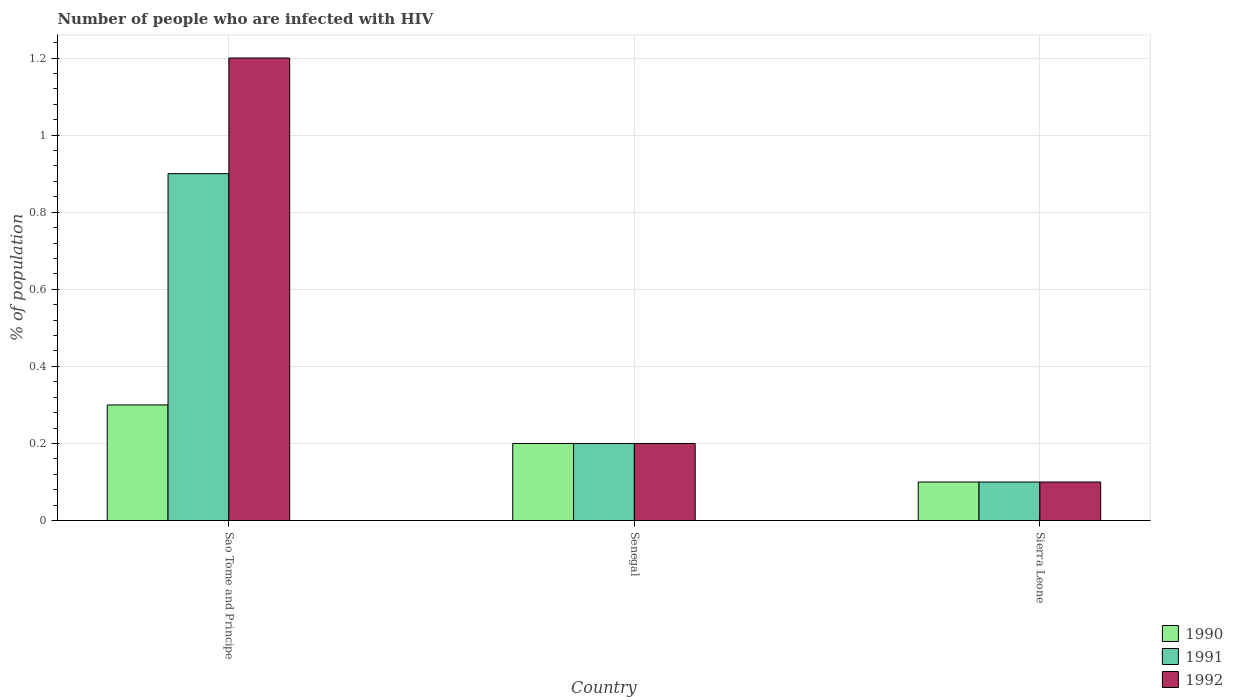Are the number of bars per tick equal to the number of legend labels?
Make the answer very short. Yes. Are the number of bars on each tick of the X-axis equal?
Provide a succinct answer. Yes. How many bars are there on the 3rd tick from the right?
Ensure brevity in your answer.  3. What is the label of the 2nd group of bars from the left?
Provide a succinct answer. Senegal. What is the percentage of HIV infected population in in 1990 in Sao Tome and Principe?
Your answer should be compact. 0.3. Across all countries, what is the maximum percentage of HIV infected population in in 1991?
Your answer should be very brief. 0.9. In which country was the percentage of HIV infected population in in 1991 maximum?
Keep it short and to the point. Sao Tome and Principe. In which country was the percentage of HIV infected population in in 1992 minimum?
Your answer should be very brief. Sierra Leone. What is the total percentage of HIV infected population in in 1990 in the graph?
Give a very brief answer. 0.6. What is the difference between the percentage of HIV infected population in in 1991 in Sao Tome and Principe and that in Sierra Leone?
Make the answer very short. 0.8. What is the difference between the percentage of HIV infected population in in 1992 in Sao Tome and Principe and the percentage of HIV infected population in in 1990 in Sierra Leone?
Your answer should be compact. 1.1. What is the average percentage of HIV infected population in in 1992 per country?
Make the answer very short. 0.5. What is the ratio of the percentage of HIV infected population in in 1992 in Sao Tome and Principe to that in Sierra Leone?
Make the answer very short. 12. What is the difference between the highest and the second highest percentage of HIV infected population in in 1992?
Ensure brevity in your answer.  -1. In how many countries, is the percentage of HIV infected population in in 1992 greater than the average percentage of HIV infected population in in 1992 taken over all countries?
Ensure brevity in your answer.  1. Is it the case that in every country, the sum of the percentage of HIV infected population in in 1991 and percentage of HIV infected population in in 1990 is greater than the percentage of HIV infected population in in 1992?
Offer a terse response. No. Are all the bars in the graph horizontal?
Provide a short and direct response. No. Does the graph contain any zero values?
Your answer should be very brief. No. How many legend labels are there?
Offer a very short reply. 3. How are the legend labels stacked?
Offer a very short reply. Vertical. What is the title of the graph?
Give a very brief answer. Number of people who are infected with HIV. What is the label or title of the Y-axis?
Your answer should be very brief. % of population. What is the % of population in 1992 in Sao Tome and Principe?
Your answer should be very brief. 1.2. What is the % of population of 1992 in Senegal?
Your answer should be compact. 0.2. What is the % of population of 1991 in Sierra Leone?
Your answer should be very brief. 0.1. What is the % of population in 1992 in Sierra Leone?
Your response must be concise. 0.1. Across all countries, what is the maximum % of population in 1991?
Keep it short and to the point. 0.9. Across all countries, what is the maximum % of population in 1992?
Provide a short and direct response. 1.2. Across all countries, what is the minimum % of population of 1990?
Offer a very short reply. 0.1. Across all countries, what is the minimum % of population of 1992?
Provide a short and direct response. 0.1. What is the difference between the % of population of 1990 in Sao Tome and Principe and that in Senegal?
Keep it short and to the point. 0.1. What is the difference between the % of population in 1992 in Sao Tome and Principe and that in Senegal?
Give a very brief answer. 1. What is the difference between the % of population of 1990 in Sao Tome and Principe and that in Sierra Leone?
Offer a very short reply. 0.2. What is the difference between the % of population in 1992 in Sao Tome and Principe and that in Sierra Leone?
Offer a terse response. 1.1. What is the difference between the % of population of 1990 in Senegal and that in Sierra Leone?
Keep it short and to the point. 0.1. What is the difference between the % of population of 1991 in Senegal and that in Sierra Leone?
Your answer should be very brief. 0.1. What is the difference between the % of population in 1992 in Senegal and that in Sierra Leone?
Your response must be concise. 0.1. What is the average % of population of 1990 per country?
Provide a succinct answer. 0.2. What is the average % of population in 1992 per country?
Give a very brief answer. 0.5. What is the difference between the % of population in 1990 and % of population in 1992 in Sao Tome and Principe?
Make the answer very short. -0.9. What is the difference between the % of population in 1990 and % of population in 1991 in Senegal?
Your answer should be compact. 0. What is the difference between the % of population in 1990 and % of population in 1991 in Sierra Leone?
Provide a short and direct response. 0. What is the ratio of the % of population in 1991 in Sao Tome and Principe to that in Senegal?
Offer a terse response. 4.5. What is the ratio of the % of population in 1990 in Sao Tome and Principe to that in Sierra Leone?
Offer a very short reply. 3. What is the ratio of the % of population in 1991 in Sao Tome and Principe to that in Sierra Leone?
Your response must be concise. 9. What is the ratio of the % of population in 1990 in Senegal to that in Sierra Leone?
Your answer should be compact. 2. What is the ratio of the % of population in 1991 in Senegal to that in Sierra Leone?
Give a very brief answer. 2. What is the ratio of the % of population of 1992 in Senegal to that in Sierra Leone?
Keep it short and to the point. 2. What is the difference between the highest and the second highest % of population in 1990?
Offer a very short reply. 0.1. What is the difference between the highest and the second highest % of population in 1991?
Your response must be concise. 0.7. What is the difference between the highest and the lowest % of population in 1990?
Provide a succinct answer. 0.2. What is the difference between the highest and the lowest % of population in 1991?
Your answer should be very brief. 0.8. 